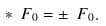Convert formula to latex. <formula><loc_0><loc_0><loc_500><loc_500>* { \ F } _ { 0 } = \pm { \ F } _ { 0 } .</formula> 